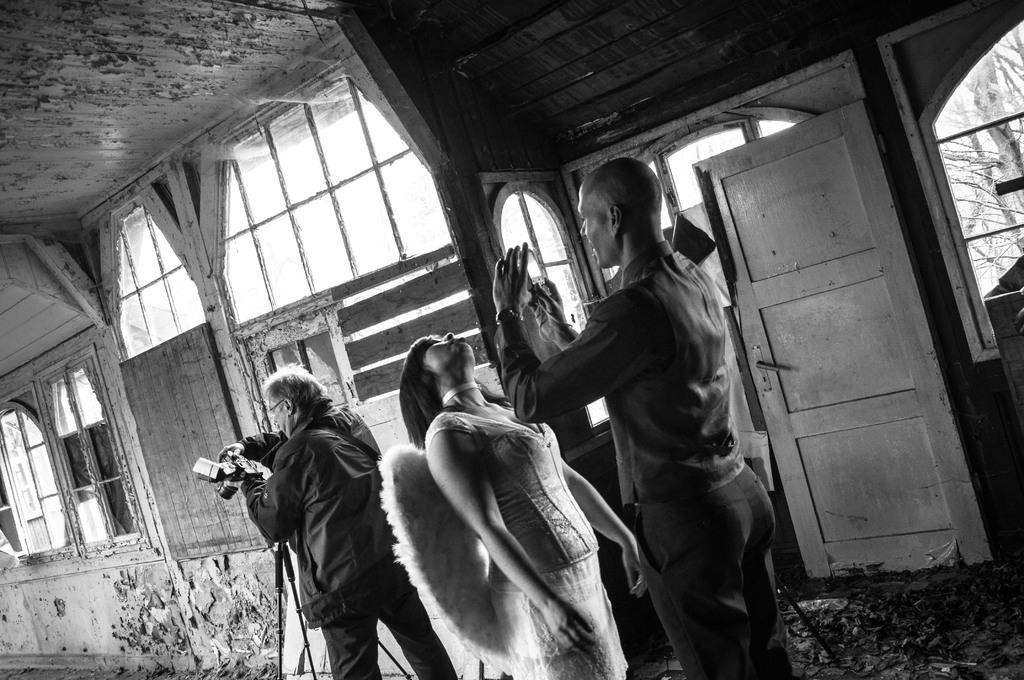In one or two sentences, can you explain what this image depicts? In this picture we can observe three members. Two of them are men and one of them is a woman. This is a black and white image. We can observe a camera. On the right side we can observe a door. We can observe some windows here. 